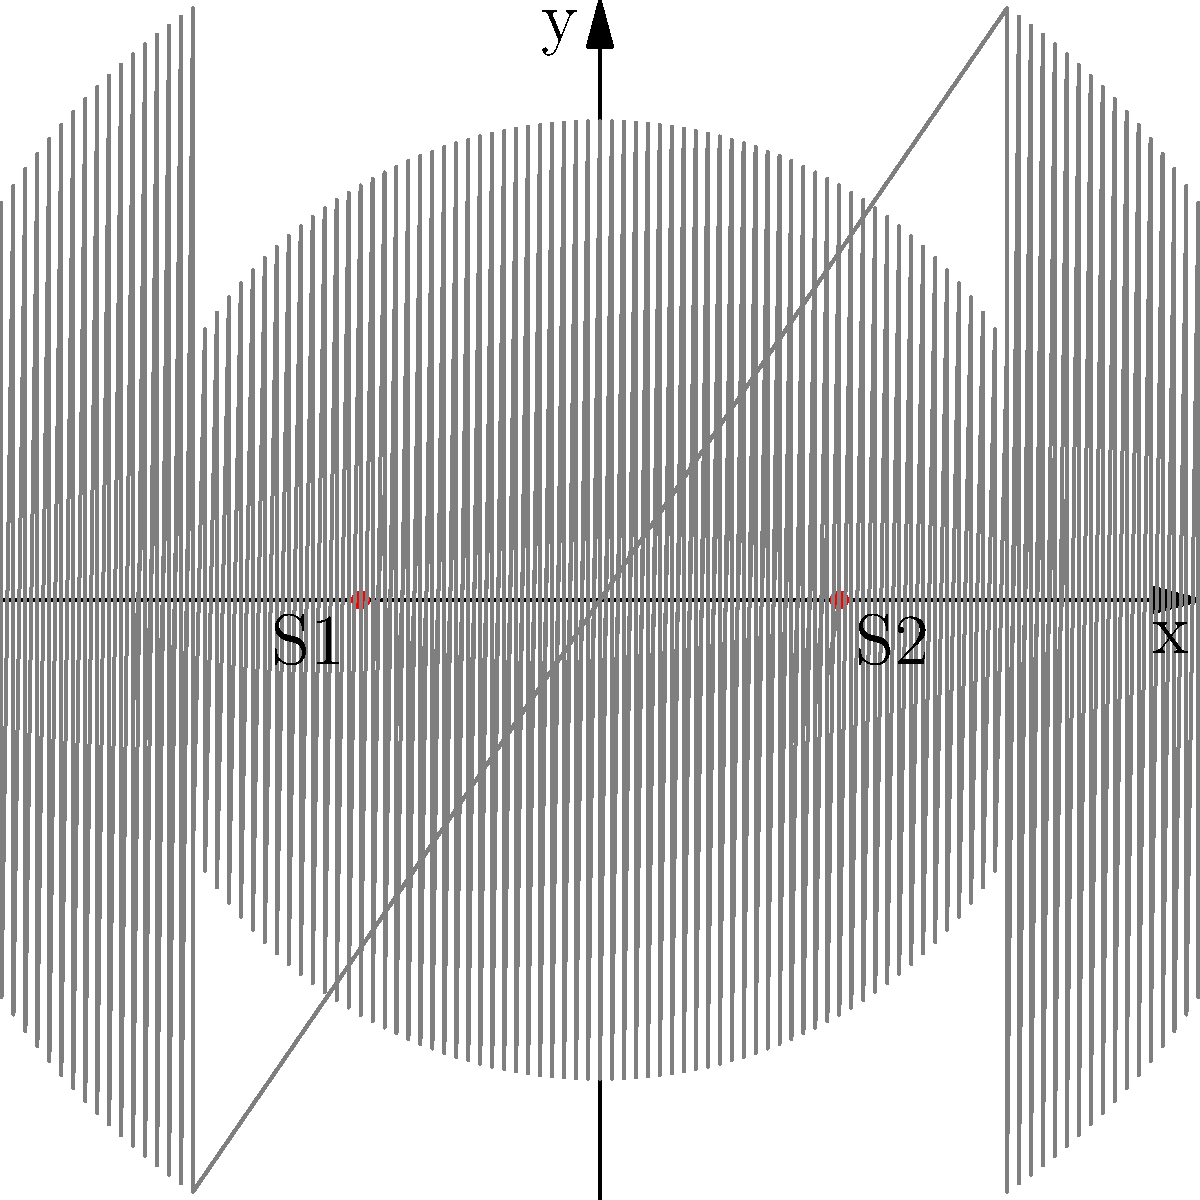In a concert hall, two speakers (S1 and S2) are placed 4 meters apart on a stage, producing identical sound waves with a wavelength of 0.5 meters. A musician wants to understand the interference pattern created by these speakers. At what perpendicular distance(s) from the line connecting the speakers will the first constructive interference maximum occur? To solve this problem, we'll follow these steps:

1) The condition for constructive interference is that the path difference between waves from the two sources must be an integer multiple of the wavelength:

   $$\Delta r = n\lambda$$
   
   where $n$ is an integer, $\lambda$ is the wavelength, and $\Delta r$ is the path difference.

2) For the first maximum, $n = 1$, so we're looking for points where:

   $$\Delta r = \lambda = 0.5\text{ m}$$

3) Let's consider a point $(x, y)$ where this occurs. The distance from this point to S1 is $r_1$, and to S2 is $r_2$. We want:

   $$r_2 - r_1 = 0.5$$

4) Using the Pythagorean theorem:

   $$r_1 = \sqrt{(x+2)^2 + y^2}$$
   $$r_2 = \sqrt{(x-2)^2 + y^2}$$

5) Substituting into our condition:

   $$\sqrt{(x-2)^2 + y^2} - \sqrt{(x+2)^2 + y^2} = 0.5$$

6) This equation describes a hyperbola. The perpendicular distance we're looking for is the y-intercept of this hyperbola (where x = 0).

7) Setting x = 0 in our equation:

   $$\sqrt{4 + y^2} - \sqrt{4 + y^2} = 0.5$$

8) Solving this equation:

   $$y = \pm\sqrt{\frac{4\lambda d}{4 - \lambda^2}}$$

   where $d$ is half the distance between the speakers (2 m in this case).

9) Plugging in our values:

   $$y = \pm\sqrt{\frac{4(0.5)(2)}{4 - 0.5^2}} = \pm\sqrt{\frac{4}{3.75}} = \pm\sqrt{\frac{16}{15}} \approx \pm1.033\text{ m}$$

Therefore, the first constructive interference maximum occurs approximately 1.033 meters above and below the line connecting the speakers.
Answer: $\pm\sqrt{\frac{16}{15}} \approx \pm1.033\text{ m}$ 